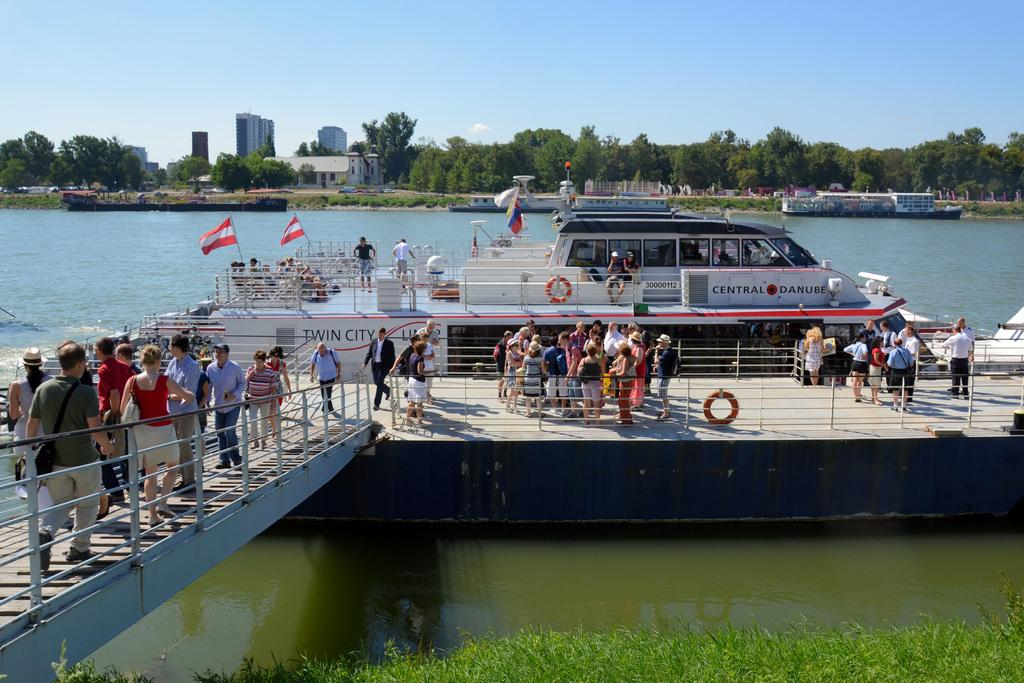What is the main subject of the image? There is a ship in the image. What else can be seen in the image besides the ship? There are people moving on a bridge beside the ship, a river, trees behind the river, and buildings behind the river. How many rings are visible on the ship in the image? There are no rings visible on the ship in the image. What type of patch is being used to fix the ship in the image? There is no patch visible on the ship in the image, and it does not appear to be in need of repair. 